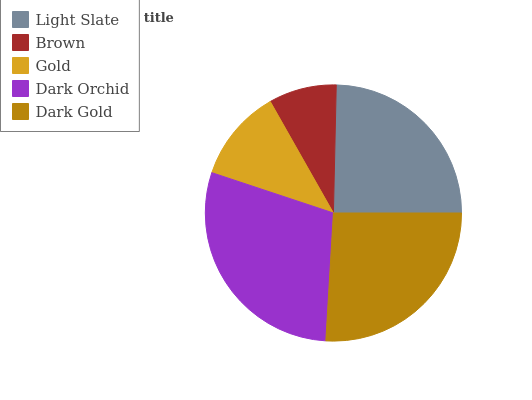Is Brown the minimum?
Answer yes or no. Yes. Is Dark Orchid the maximum?
Answer yes or no. Yes. Is Gold the minimum?
Answer yes or no. No. Is Gold the maximum?
Answer yes or no. No. Is Gold greater than Brown?
Answer yes or no. Yes. Is Brown less than Gold?
Answer yes or no. Yes. Is Brown greater than Gold?
Answer yes or no. No. Is Gold less than Brown?
Answer yes or no. No. Is Light Slate the high median?
Answer yes or no. Yes. Is Light Slate the low median?
Answer yes or no. Yes. Is Dark Gold the high median?
Answer yes or no. No. Is Dark Gold the low median?
Answer yes or no. No. 